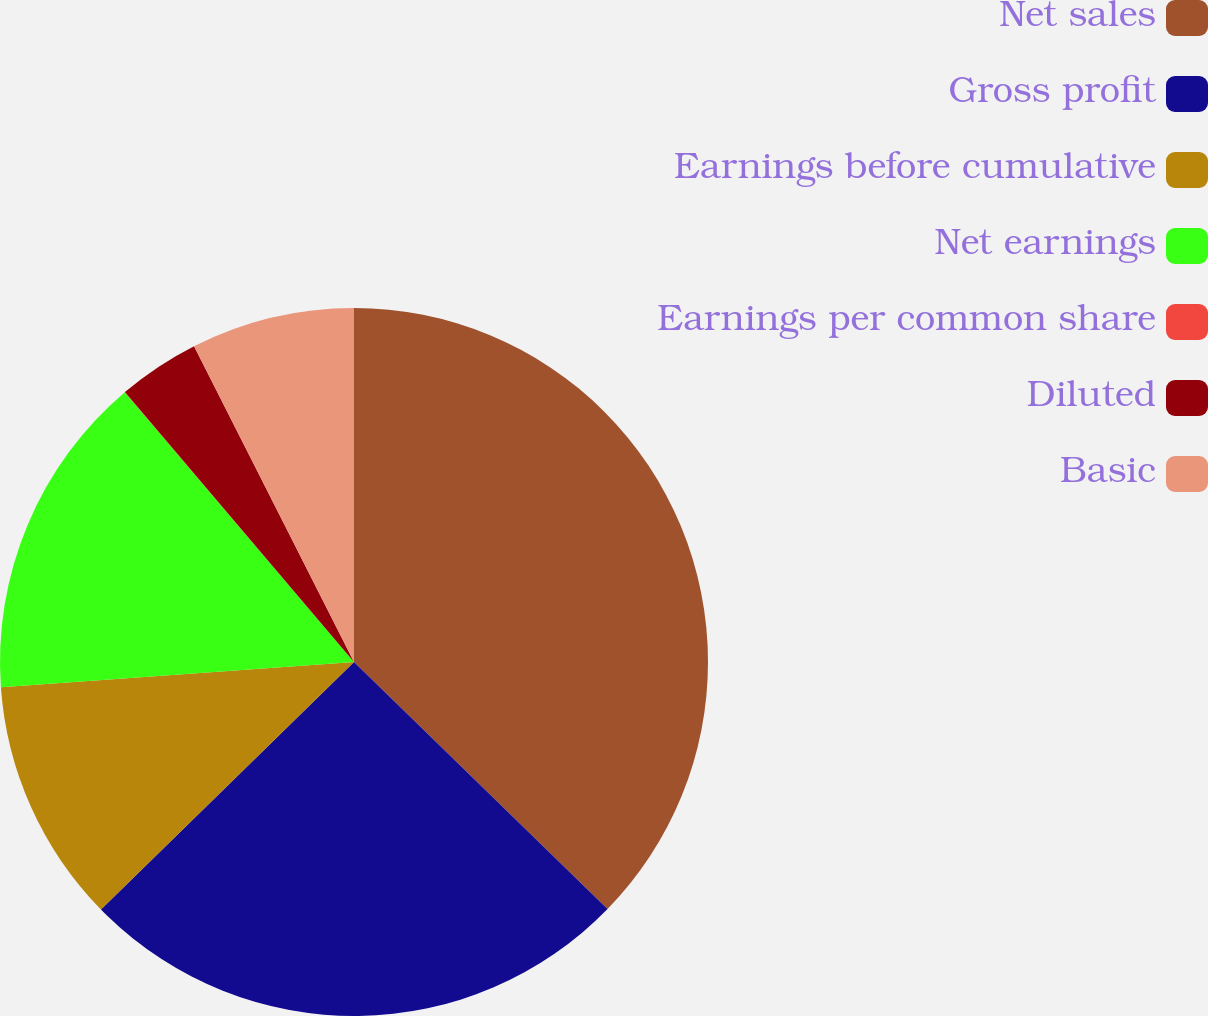<chart> <loc_0><loc_0><loc_500><loc_500><pie_chart><fcel>Net sales<fcel>Gross profit<fcel>Earnings before cumulative<fcel>Net earnings<fcel>Earnings per common share<fcel>Diluted<fcel>Basic<nl><fcel>37.29%<fcel>25.38%<fcel>11.19%<fcel>14.92%<fcel>0.01%<fcel>3.74%<fcel>7.46%<nl></chart> 